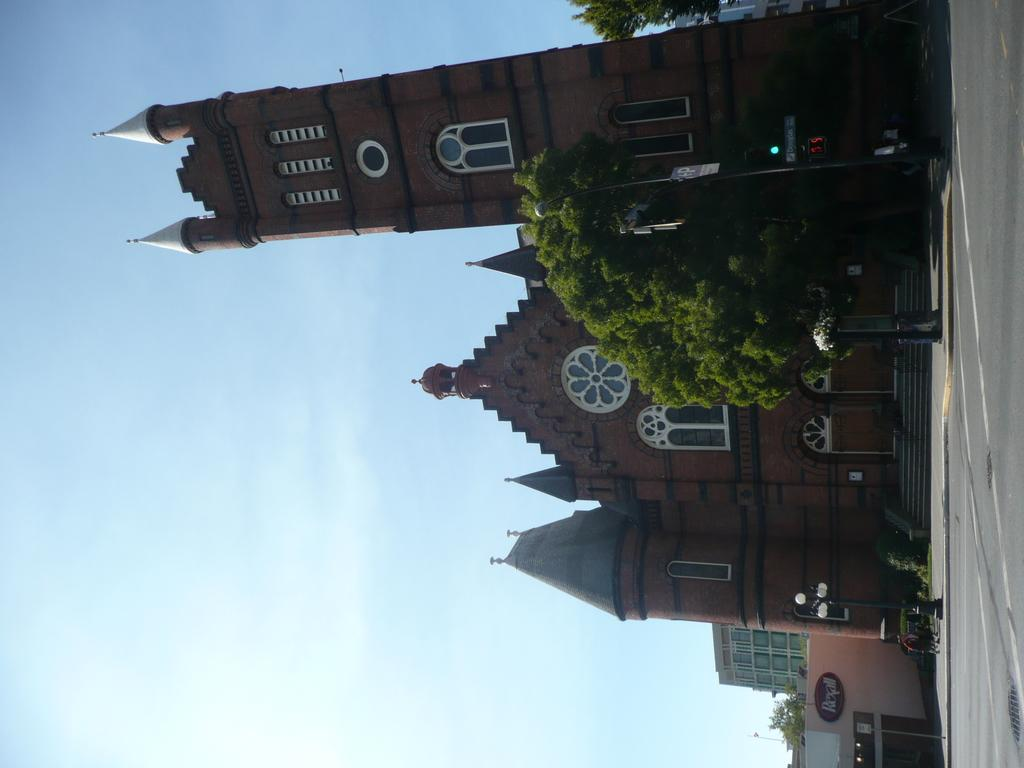What type of structures can be seen in the image? There are buildings in the image. What natural elements are present in the image? There are trees in the image. What are the vertical objects in the image? There are poles in the image. What are the flat, rectangular objects in the image? There are boards in the image. What architectural feature is present in the image? There are stairs in the image. What part of the ground can be seen in the image? The ground is visible in the image. What objects are on the ground in the image? There are objects on the ground in the image. What part of the natural environment is visible in the image? The sky is visible in the image. What type of appliance can be seen in the field in the image? There is no field or appliance present in the image. What sound can be heard coming from the buildings in the image? The image does not provide any information about sounds, so it cannot be determined what sounds might be heard. 